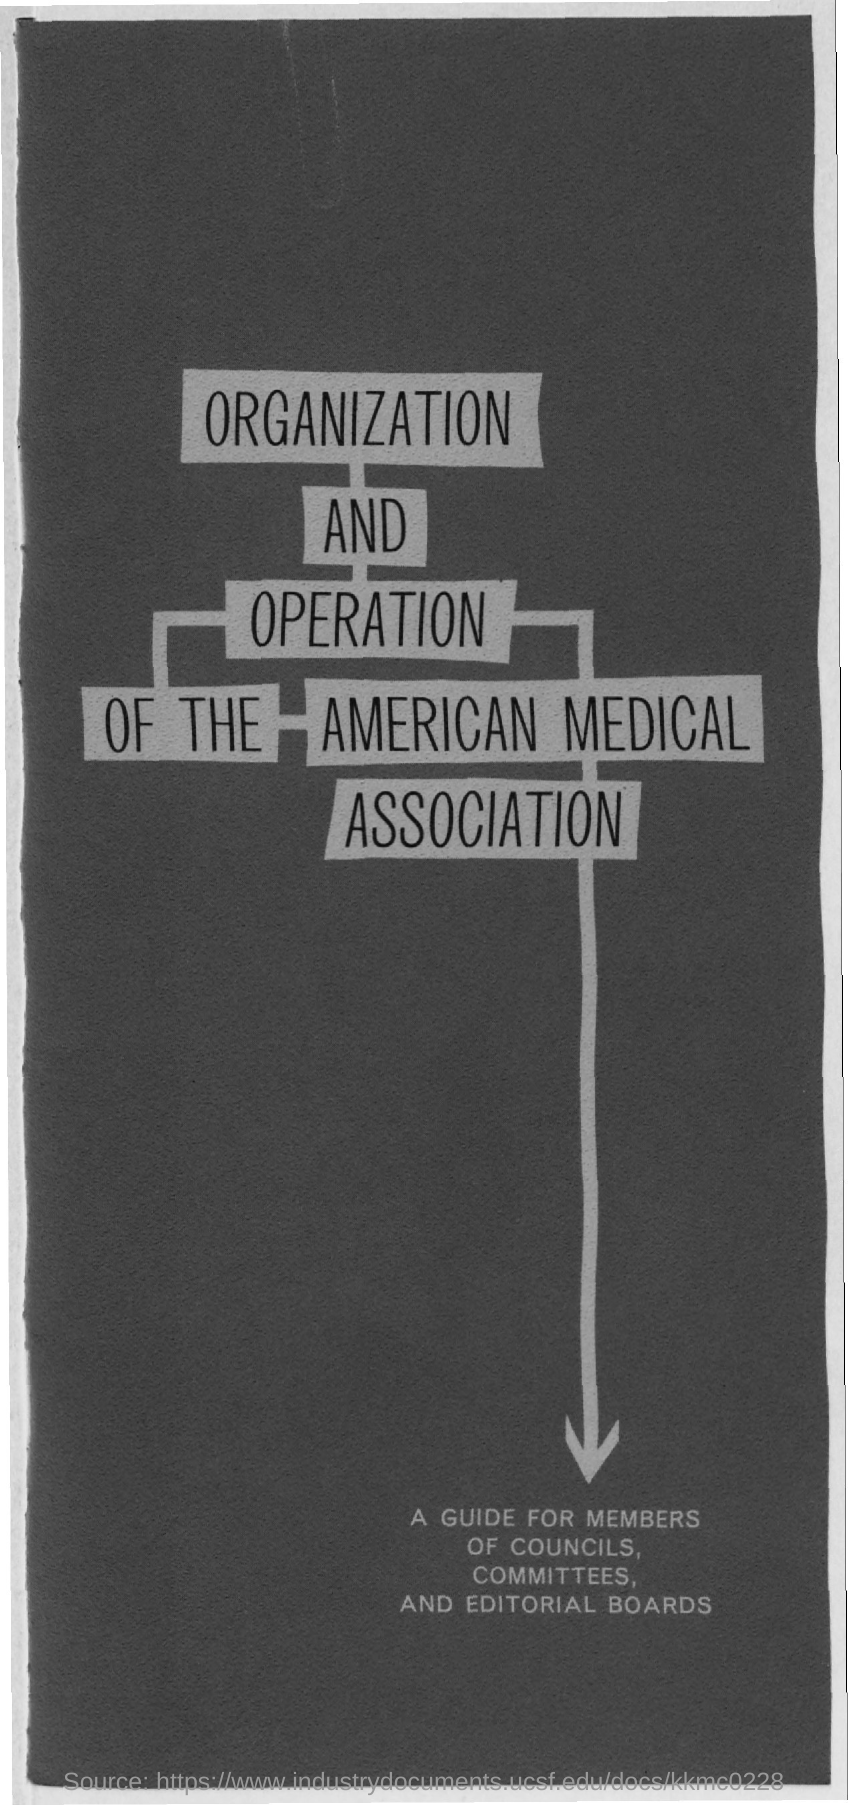What is the title of the document?
Make the answer very short. Organization and operation of the american medical association. 